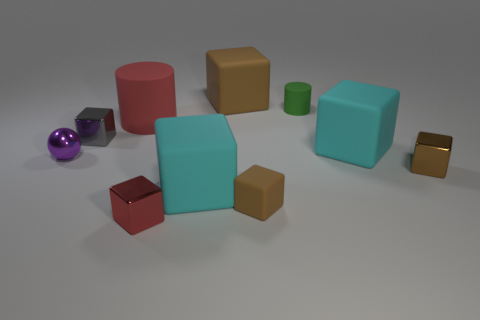Subtract all red cubes. How many cubes are left? 6 Subtract all blue cylinders. How many cyan cubes are left? 2 Subtract 4 blocks. How many blocks are left? 3 Subtract all brown cubes. How many cubes are left? 4 Subtract all red cubes. Subtract all cyan cylinders. How many cubes are left? 6 Subtract 2 cyan cubes. How many objects are left? 8 Subtract all cubes. How many objects are left? 3 Subtract all small red shiny objects. Subtract all small metallic blocks. How many objects are left? 6 Add 5 red matte cylinders. How many red matte cylinders are left? 6 Add 8 red blocks. How many red blocks exist? 9 